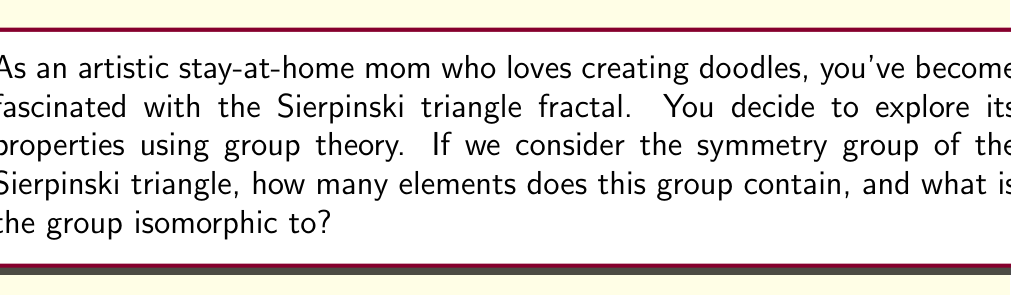Provide a solution to this math problem. Let's approach this step-by-step:

1) First, we need to understand the symmetries of the Sierpinski triangle. The Sierpinski triangle has three types of symmetries:
   - Identity (do nothing)
   - Rotations by 120° and 240°
   - Reflections across three axes of symmetry

2) Let's count these symmetries:
   - 1 identity transformation
   - 2 rotations (120° and 240°)
   - 3 reflections

3) In total, we have 1 + 2 + 3 = 6 symmetries. This means the symmetry group has 6 elements.

4) Now, we need to identify which group of order 6 this is isomorphic to. There are two possibilities:
   - Cyclic group of order 6, $C_6$
   - Dihedral group of order 6, $D_3$

5) The key difference is that $C_6$ has an element of order 6, while $D_3$ does not.

6) In the Sierpinski triangle symmetry group:
   - Rotations have order 3 (rotating 3 times brings us back to the start)
   - Reflections have order 2
   - No element has order 6

7) This structure matches $D_3$, which is generated by a rotation of order 3 and a reflection of order 2.

8) We can confirm this by noting that $D_3$ is the symmetry group of an equilateral triangle, which shares the same symmetries as the Sierpinski triangle.

Therefore, the symmetry group of the Sierpinski triangle has 6 elements and is isomorphic to $D_3$.
Answer: The symmetry group of the Sierpinski triangle contains 6 elements and is isomorphic to $D_3$, the dihedral group of order 6. 